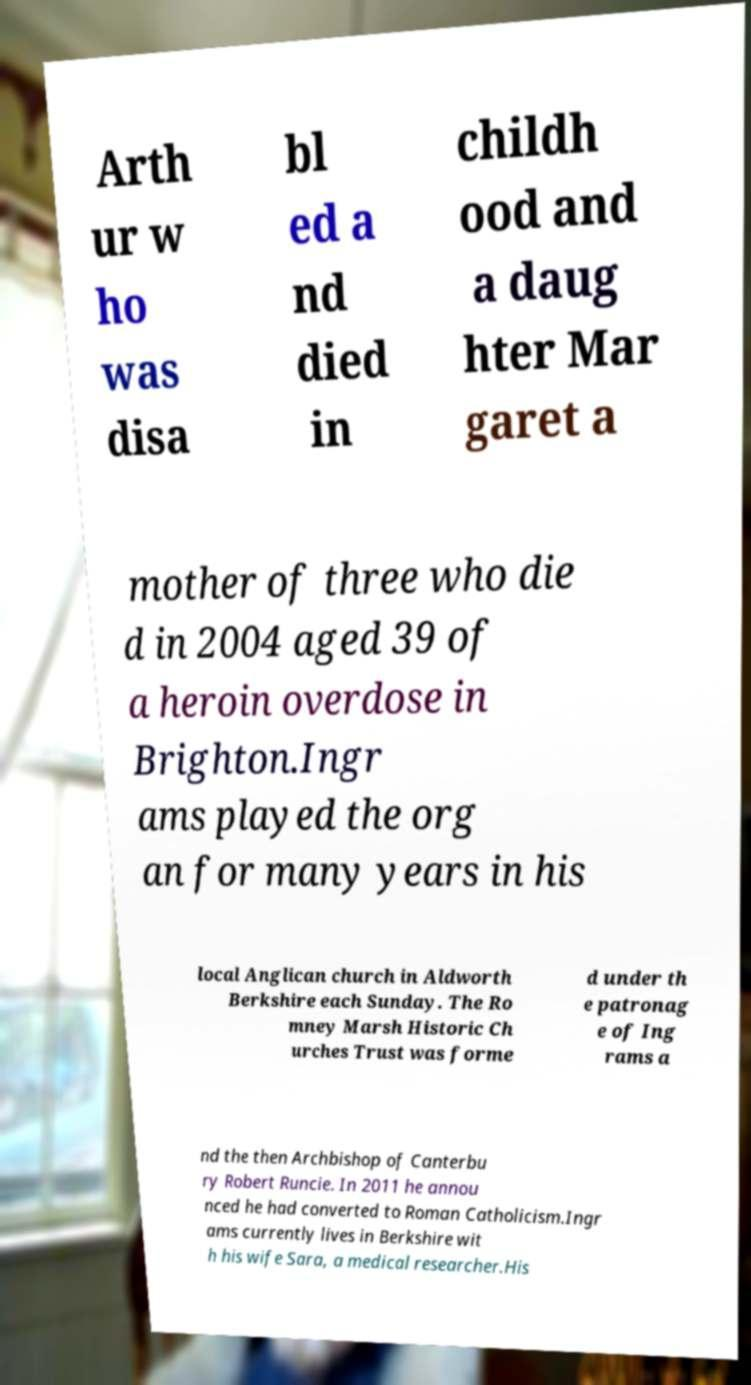Can you read and provide the text displayed in the image?This photo seems to have some interesting text. Can you extract and type it out for me? Arth ur w ho was disa bl ed a nd died in childh ood and a daug hter Mar garet a mother of three who die d in 2004 aged 39 of a heroin overdose in Brighton.Ingr ams played the org an for many years in his local Anglican church in Aldworth Berkshire each Sunday. The Ro mney Marsh Historic Ch urches Trust was forme d under th e patronag e of Ing rams a nd the then Archbishop of Canterbu ry Robert Runcie. In 2011 he annou nced he had converted to Roman Catholicism.Ingr ams currently lives in Berkshire wit h his wife Sara, a medical researcher.His 